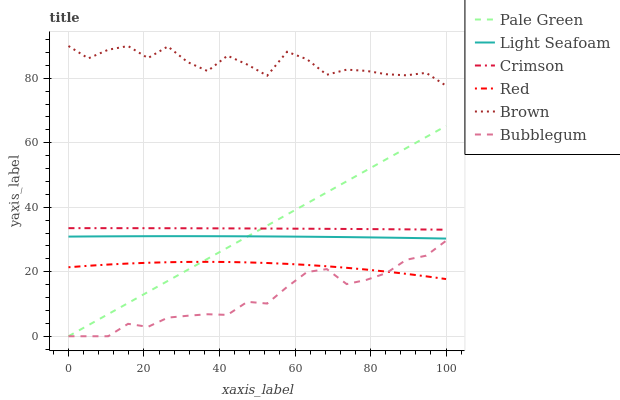Does Bubblegum have the minimum area under the curve?
Answer yes or no. Yes. Does Brown have the maximum area under the curve?
Answer yes or no. Yes. Does Pale Green have the minimum area under the curve?
Answer yes or no. No. Does Pale Green have the maximum area under the curve?
Answer yes or no. No. Is Pale Green the smoothest?
Answer yes or no. Yes. Is Brown the roughest?
Answer yes or no. Yes. Is Bubblegum the smoothest?
Answer yes or no. No. Is Bubblegum the roughest?
Answer yes or no. No. Does Bubblegum have the lowest value?
Answer yes or no. Yes. Does Crimson have the lowest value?
Answer yes or no. No. Does Brown have the highest value?
Answer yes or no. Yes. Does Bubblegum have the highest value?
Answer yes or no. No. Is Bubblegum less than Brown?
Answer yes or no. Yes. Is Light Seafoam greater than Bubblegum?
Answer yes or no. Yes. Does Light Seafoam intersect Pale Green?
Answer yes or no. Yes. Is Light Seafoam less than Pale Green?
Answer yes or no. No. Is Light Seafoam greater than Pale Green?
Answer yes or no. No. Does Bubblegum intersect Brown?
Answer yes or no. No. 